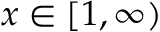<formula> <loc_0><loc_0><loc_500><loc_500>x \in [ 1 , \infty )</formula> 